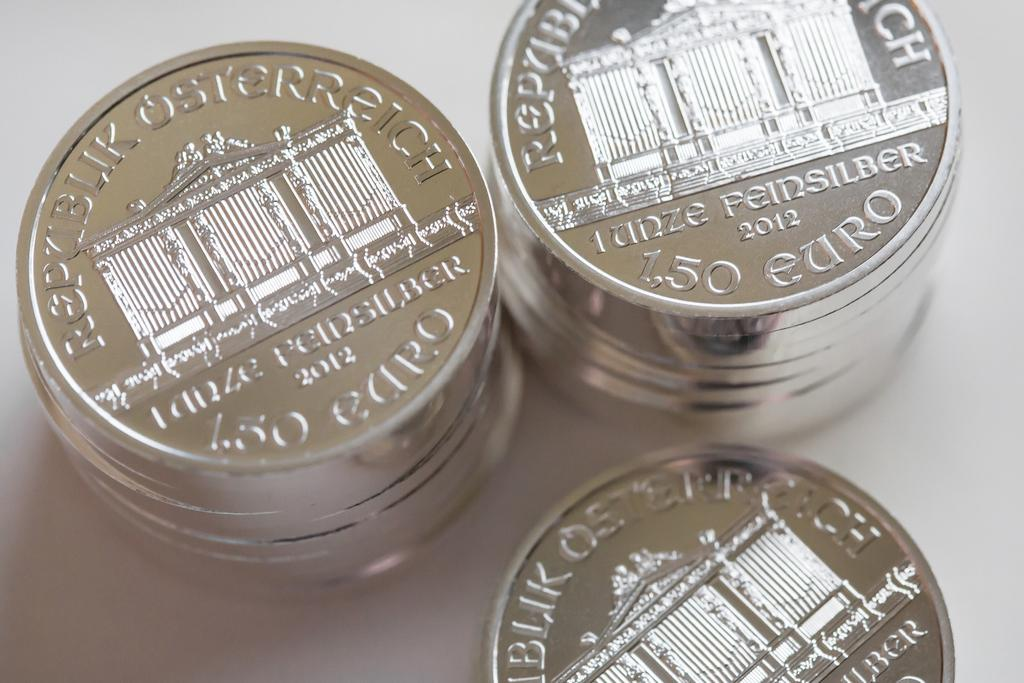What type of currency is depicted in the image? There are euro coins in the image. What is the color of the surface on which the euro coins are placed? The euro coins are on a white surface. What type of animal is cooking in the oven in the image? There is no oven or animal present in the image; it only features euro coins on a white surface. 